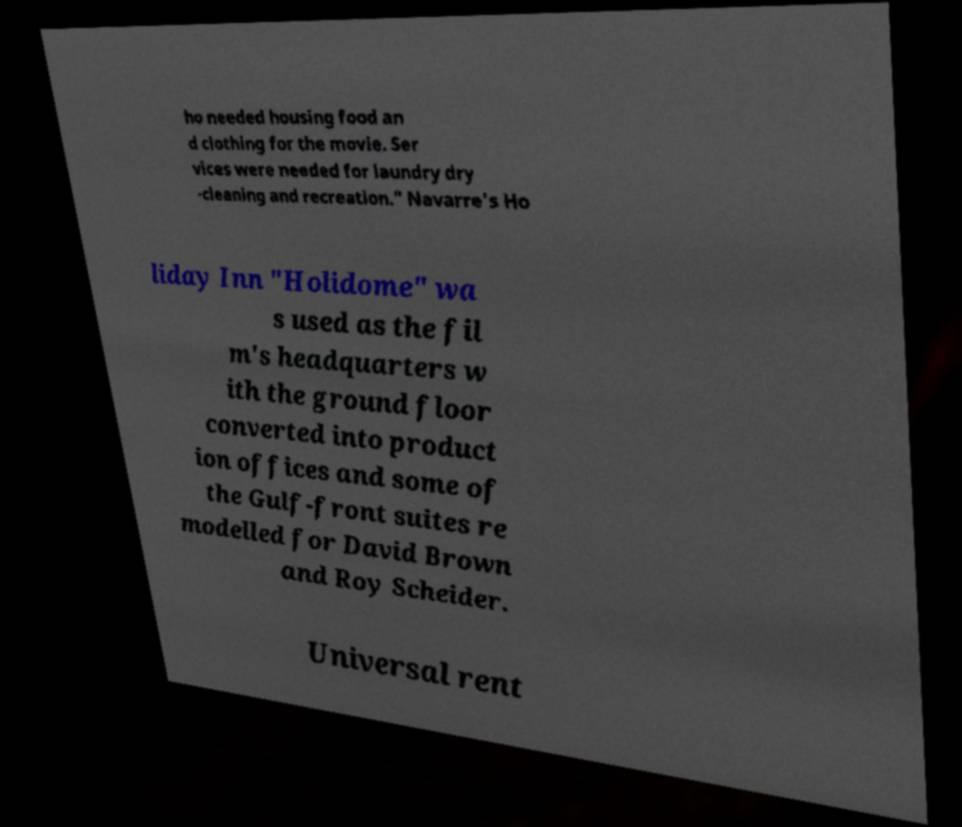Can you read and provide the text displayed in the image?This photo seems to have some interesting text. Can you extract and type it out for me? ho needed housing food an d clothing for the movie. Ser vices were needed for laundry dry -cleaning and recreation." Navarre's Ho liday Inn "Holidome" wa s used as the fil m's headquarters w ith the ground floor converted into product ion offices and some of the Gulf-front suites re modelled for David Brown and Roy Scheider. Universal rent 